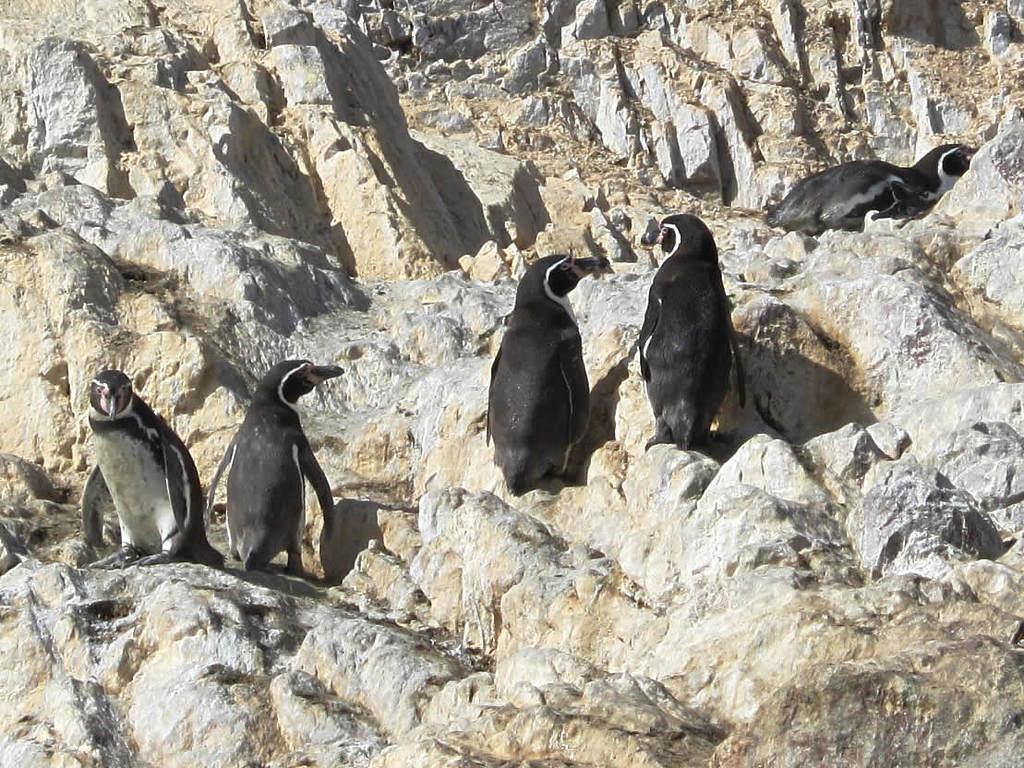How many penguins are present in the image? There are five penguins in the image. Where are the penguins located? The penguins are standing on a mountain. What type of hospital can be seen in the image? There is no hospital present in the image; it features five penguins standing on a mountain. 